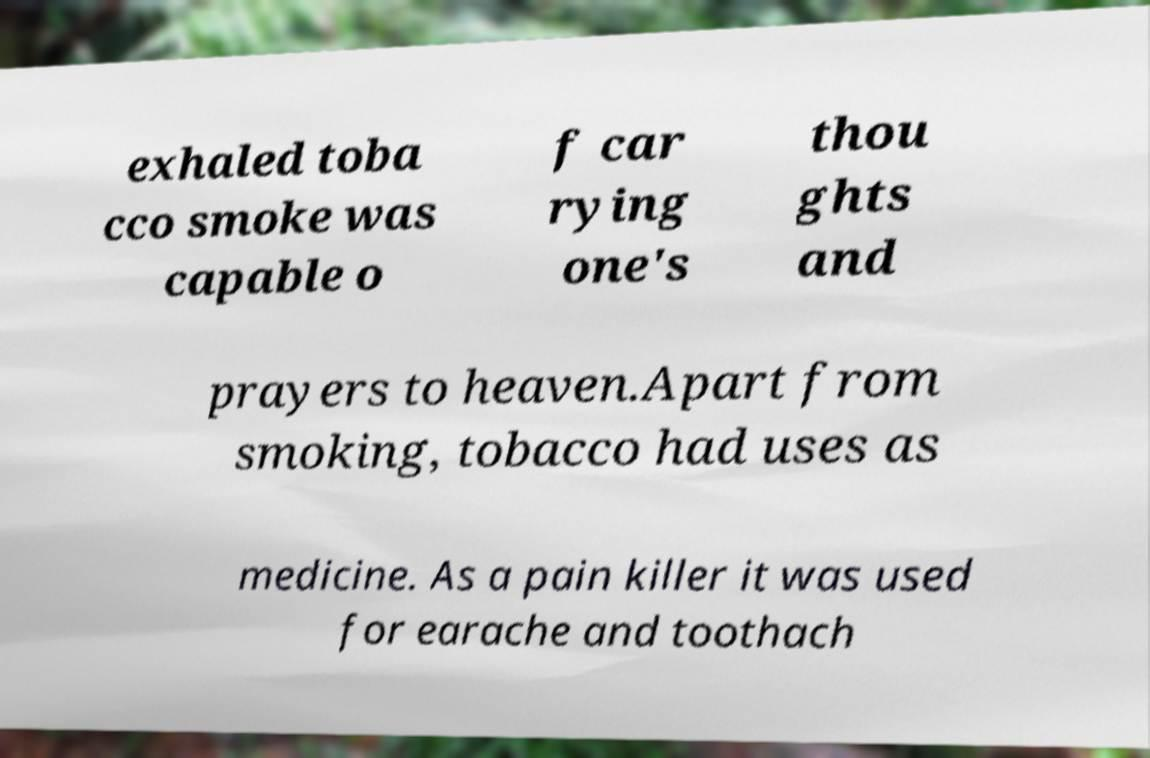I need the written content from this picture converted into text. Can you do that? exhaled toba cco smoke was capable o f car rying one's thou ghts and prayers to heaven.Apart from smoking, tobacco had uses as medicine. As a pain killer it was used for earache and toothach 